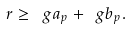<formula> <loc_0><loc_0><loc_500><loc_500>r \geq \ g a _ { p } + \ g b _ { p } .</formula> 